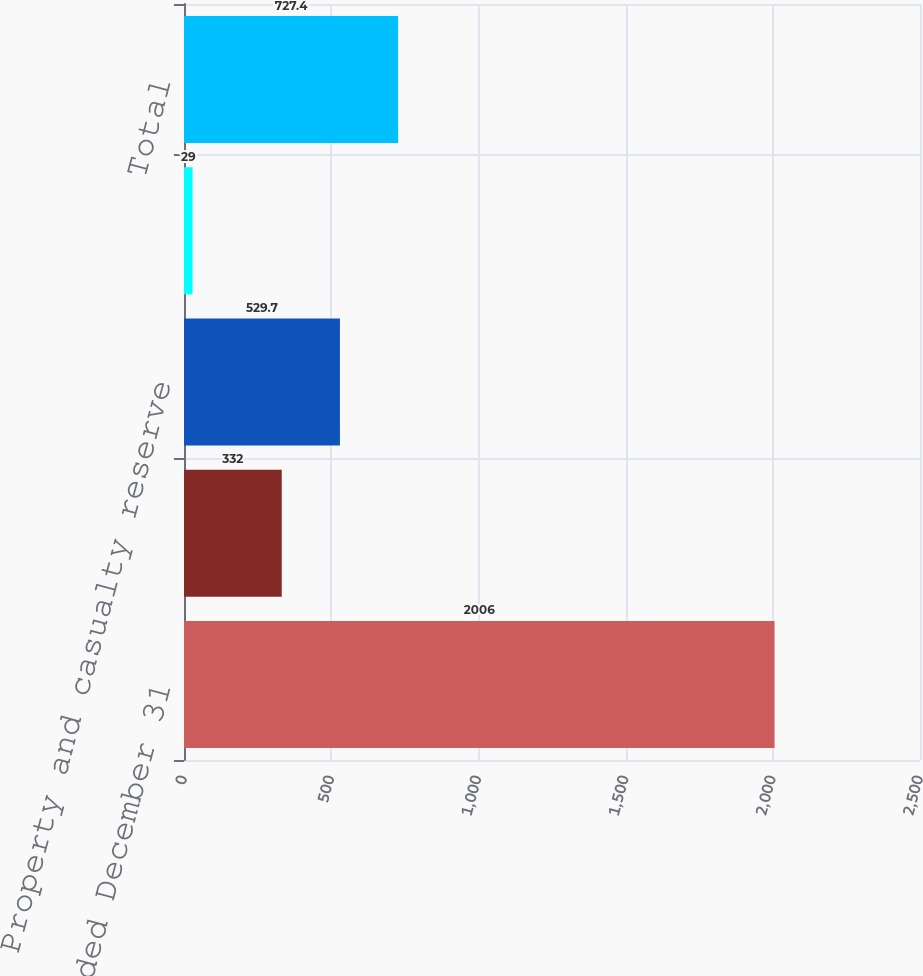<chart> <loc_0><loc_0><loc_500><loc_500><bar_chart><fcel>Year Ended December 31<fcel>Other<fcel>Property and casualty reserve<fcel>Life reserve development in<fcel>Total<nl><fcel>2006<fcel>332<fcel>529.7<fcel>29<fcel>727.4<nl></chart> 